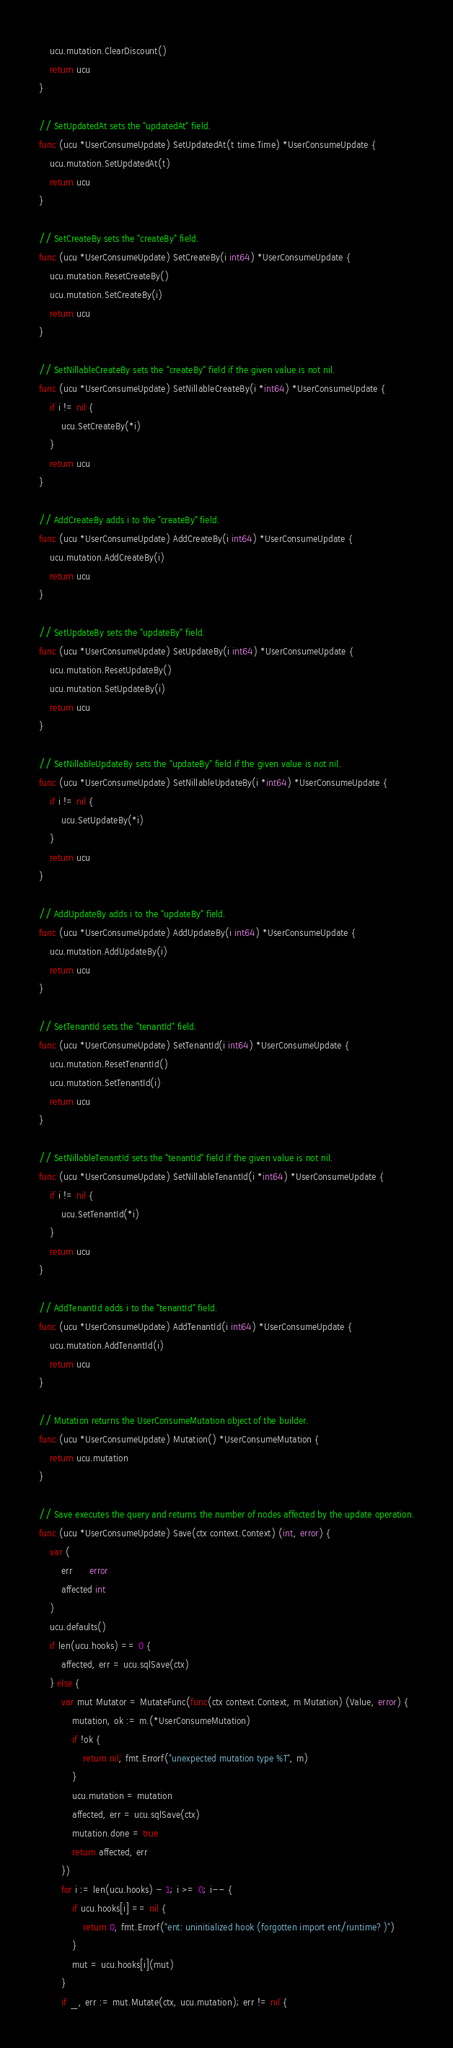<code> <loc_0><loc_0><loc_500><loc_500><_Go_>	ucu.mutation.ClearDiscount()
	return ucu
}

// SetUpdatedAt sets the "updatedAt" field.
func (ucu *UserConsumeUpdate) SetUpdatedAt(t time.Time) *UserConsumeUpdate {
	ucu.mutation.SetUpdatedAt(t)
	return ucu
}

// SetCreateBy sets the "createBy" field.
func (ucu *UserConsumeUpdate) SetCreateBy(i int64) *UserConsumeUpdate {
	ucu.mutation.ResetCreateBy()
	ucu.mutation.SetCreateBy(i)
	return ucu
}

// SetNillableCreateBy sets the "createBy" field if the given value is not nil.
func (ucu *UserConsumeUpdate) SetNillableCreateBy(i *int64) *UserConsumeUpdate {
	if i != nil {
		ucu.SetCreateBy(*i)
	}
	return ucu
}

// AddCreateBy adds i to the "createBy" field.
func (ucu *UserConsumeUpdate) AddCreateBy(i int64) *UserConsumeUpdate {
	ucu.mutation.AddCreateBy(i)
	return ucu
}

// SetUpdateBy sets the "updateBy" field.
func (ucu *UserConsumeUpdate) SetUpdateBy(i int64) *UserConsumeUpdate {
	ucu.mutation.ResetUpdateBy()
	ucu.mutation.SetUpdateBy(i)
	return ucu
}

// SetNillableUpdateBy sets the "updateBy" field if the given value is not nil.
func (ucu *UserConsumeUpdate) SetNillableUpdateBy(i *int64) *UserConsumeUpdate {
	if i != nil {
		ucu.SetUpdateBy(*i)
	}
	return ucu
}

// AddUpdateBy adds i to the "updateBy" field.
func (ucu *UserConsumeUpdate) AddUpdateBy(i int64) *UserConsumeUpdate {
	ucu.mutation.AddUpdateBy(i)
	return ucu
}

// SetTenantId sets the "tenantId" field.
func (ucu *UserConsumeUpdate) SetTenantId(i int64) *UserConsumeUpdate {
	ucu.mutation.ResetTenantId()
	ucu.mutation.SetTenantId(i)
	return ucu
}

// SetNillableTenantId sets the "tenantId" field if the given value is not nil.
func (ucu *UserConsumeUpdate) SetNillableTenantId(i *int64) *UserConsumeUpdate {
	if i != nil {
		ucu.SetTenantId(*i)
	}
	return ucu
}

// AddTenantId adds i to the "tenantId" field.
func (ucu *UserConsumeUpdate) AddTenantId(i int64) *UserConsumeUpdate {
	ucu.mutation.AddTenantId(i)
	return ucu
}

// Mutation returns the UserConsumeMutation object of the builder.
func (ucu *UserConsumeUpdate) Mutation() *UserConsumeMutation {
	return ucu.mutation
}

// Save executes the query and returns the number of nodes affected by the update operation.
func (ucu *UserConsumeUpdate) Save(ctx context.Context) (int, error) {
	var (
		err      error
		affected int
	)
	ucu.defaults()
	if len(ucu.hooks) == 0 {
		affected, err = ucu.sqlSave(ctx)
	} else {
		var mut Mutator = MutateFunc(func(ctx context.Context, m Mutation) (Value, error) {
			mutation, ok := m.(*UserConsumeMutation)
			if !ok {
				return nil, fmt.Errorf("unexpected mutation type %T", m)
			}
			ucu.mutation = mutation
			affected, err = ucu.sqlSave(ctx)
			mutation.done = true
			return affected, err
		})
		for i := len(ucu.hooks) - 1; i >= 0; i-- {
			if ucu.hooks[i] == nil {
				return 0, fmt.Errorf("ent: uninitialized hook (forgotten import ent/runtime?)")
			}
			mut = ucu.hooks[i](mut)
		}
		if _, err := mut.Mutate(ctx, ucu.mutation); err != nil {</code> 